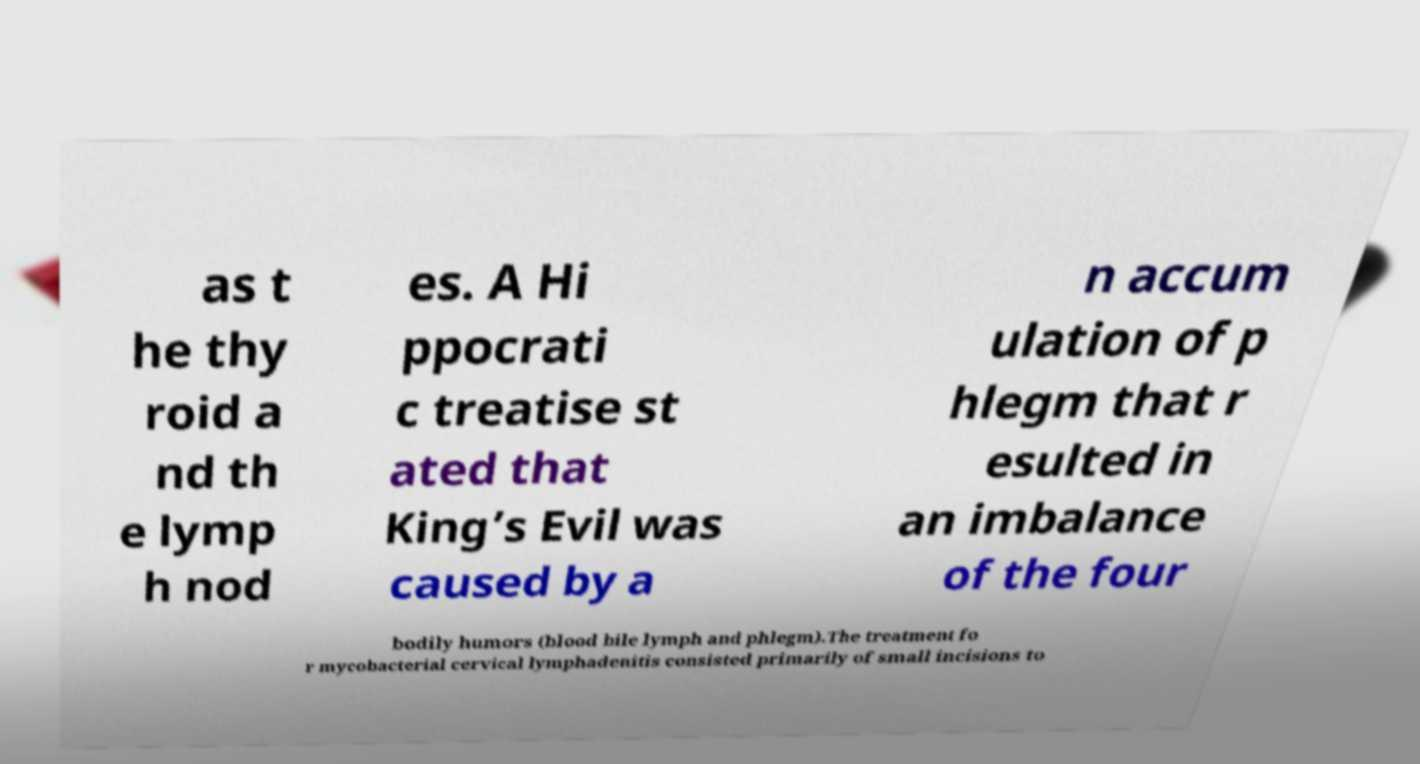There's text embedded in this image that I need extracted. Can you transcribe it verbatim? as t he thy roid a nd th e lymp h nod es. A Hi ppocrati c treatise st ated that King’s Evil was caused by a n accum ulation of p hlegm that r esulted in an imbalance of the four bodily humors (blood bile lymph and phlegm).The treatment fo r mycobacterial cervical lymphadenitis consisted primarily of small incisions to 